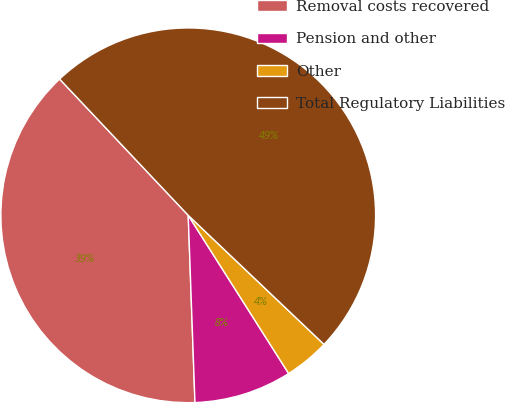Convert chart to OTSL. <chart><loc_0><loc_0><loc_500><loc_500><pie_chart><fcel>Removal costs recovered<fcel>Pension and other<fcel>Other<fcel>Total Regulatory Liabilities<nl><fcel>38.53%<fcel>8.43%<fcel>3.9%<fcel>49.14%<nl></chart> 